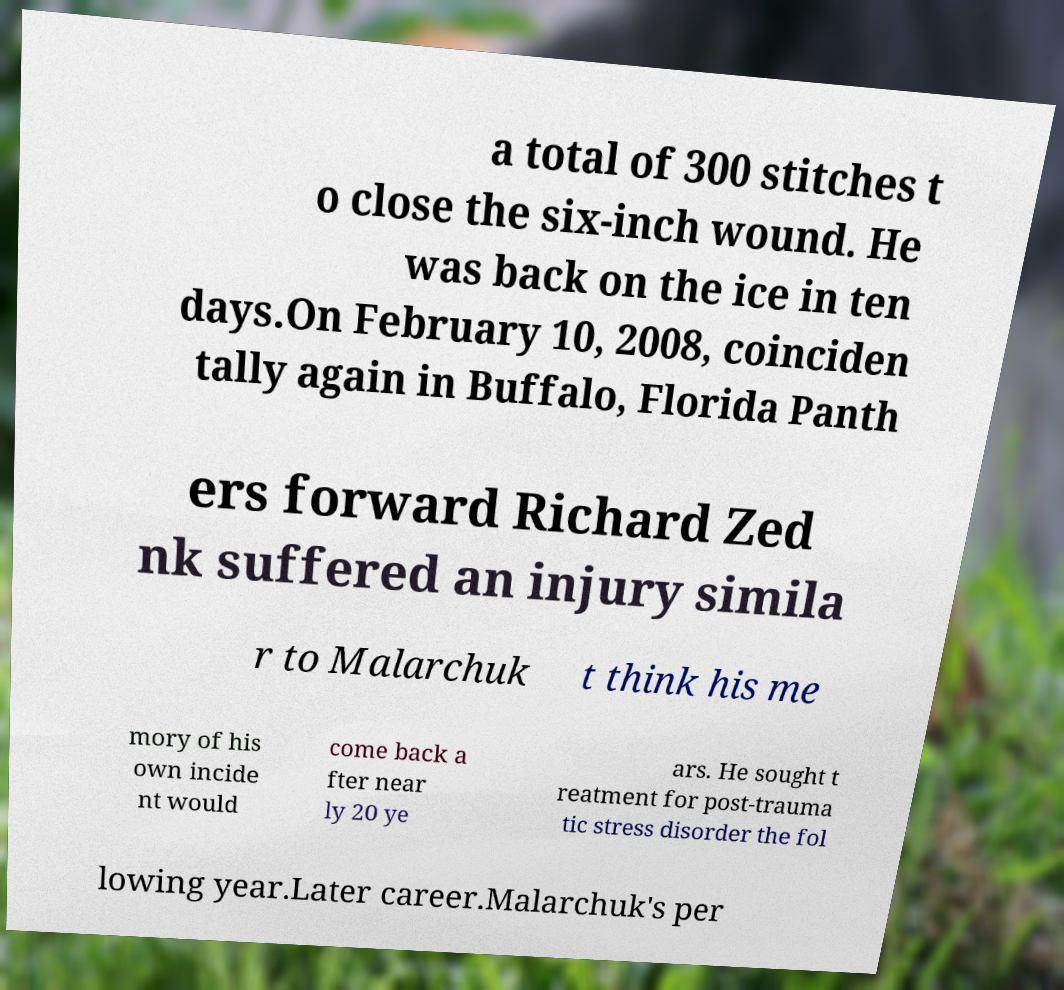I need the written content from this picture converted into text. Can you do that? a total of 300 stitches t o close the six-inch wound. He was back on the ice in ten days.On February 10, 2008, coinciden tally again in Buffalo, Florida Panth ers forward Richard Zed nk suffered an injury simila r to Malarchuk t think his me mory of his own incide nt would come back a fter near ly 20 ye ars. He sought t reatment for post-trauma tic stress disorder the fol lowing year.Later career.Malarchuk's per 